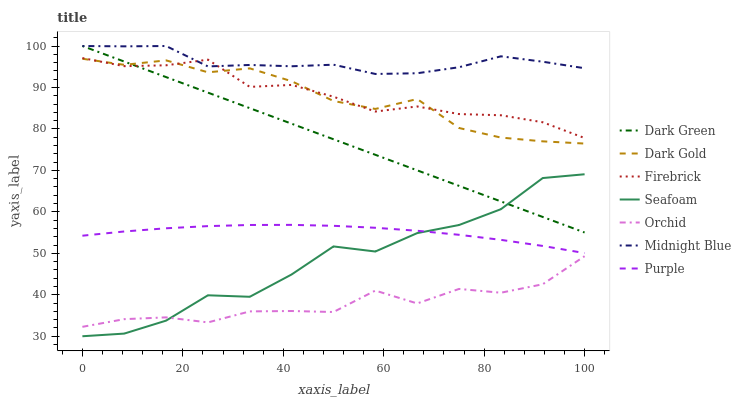Does Orchid have the minimum area under the curve?
Answer yes or no. Yes. Does Midnight Blue have the maximum area under the curve?
Answer yes or no. Yes. Does Dark Gold have the minimum area under the curve?
Answer yes or no. No. Does Dark Gold have the maximum area under the curve?
Answer yes or no. No. Is Dark Green the smoothest?
Answer yes or no. Yes. Is Seafoam the roughest?
Answer yes or no. Yes. Is Dark Gold the smoothest?
Answer yes or no. No. Is Dark Gold the roughest?
Answer yes or no. No. Does Seafoam have the lowest value?
Answer yes or no. Yes. Does Dark Gold have the lowest value?
Answer yes or no. No. Does Dark Green have the highest value?
Answer yes or no. Yes. Does Dark Gold have the highest value?
Answer yes or no. No. Is Purple less than Firebrick?
Answer yes or no. Yes. Is Purple greater than Orchid?
Answer yes or no. Yes. Does Dark Green intersect Seafoam?
Answer yes or no. Yes. Is Dark Green less than Seafoam?
Answer yes or no. No. Is Dark Green greater than Seafoam?
Answer yes or no. No. Does Purple intersect Firebrick?
Answer yes or no. No. 